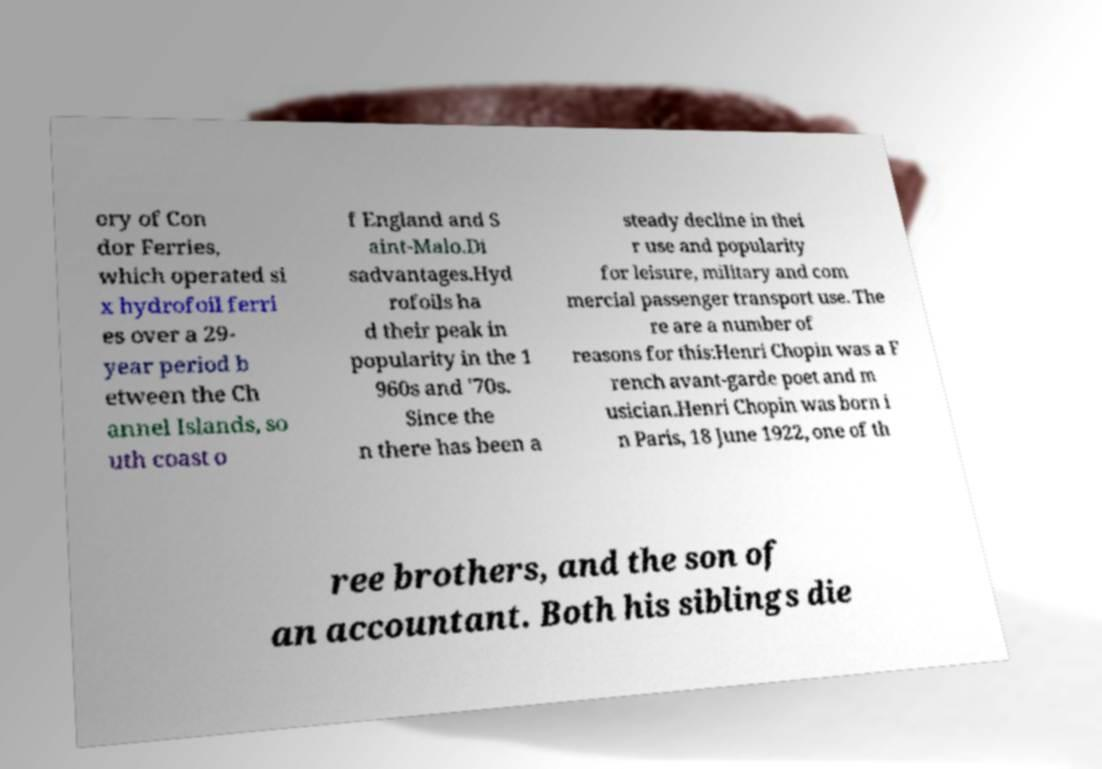Could you assist in decoding the text presented in this image and type it out clearly? ory of Con dor Ferries, which operated si x hydrofoil ferri es over a 29- year period b etween the Ch annel Islands, so uth coast o f England and S aint-Malo.Di sadvantages.Hyd rofoils ha d their peak in popularity in the 1 960s and '70s. Since the n there has been a steady decline in thei r use and popularity for leisure, military and com mercial passenger transport use. The re are a number of reasons for this:Henri Chopin was a F rench avant-garde poet and m usician.Henri Chopin was born i n Paris, 18 June 1922, one of th ree brothers, and the son of an accountant. Both his siblings die 